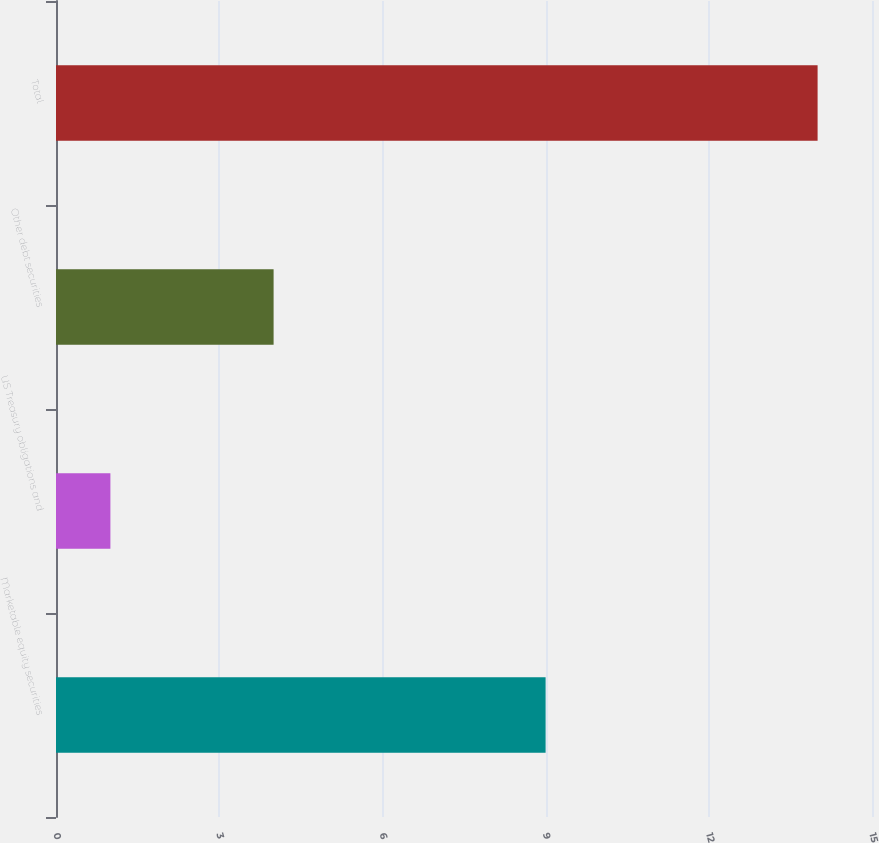<chart> <loc_0><loc_0><loc_500><loc_500><bar_chart><fcel>Marketable equity securities<fcel>US Treasury obligations and<fcel>Other debt securities<fcel>Total<nl><fcel>9<fcel>1<fcel>4<fcel>14<nl></chart> 